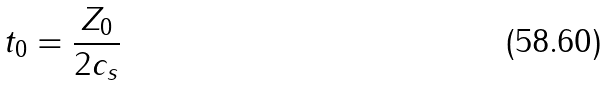Convert formula to latex. <formula><loc_0><loc_0><loc_500><loc_500>t _ { 0 } = \frac { Z _ { 0 } } { 2 c _ { s } }</formula> 